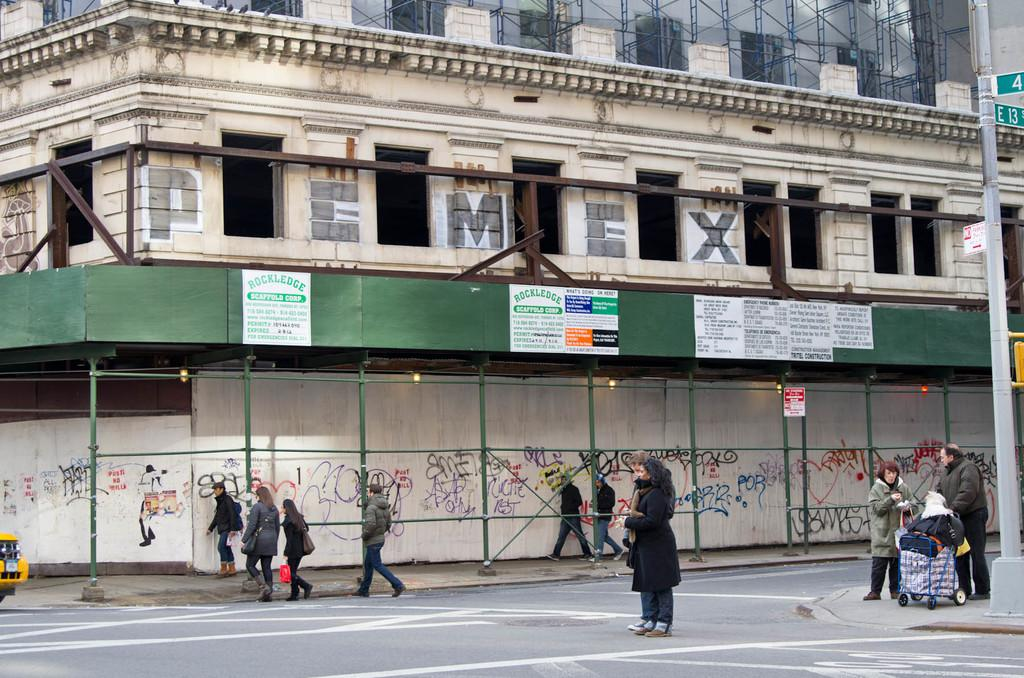<image>
Create a compact narrative representing the image presented. A woman standing in front of a building with the word PEMEX on top. 